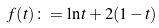<formula> <loc_0><loc_0><loc_500><loc_500>f ( t ) \colon = \ln t + 2 ( 1 - t )</formula> 